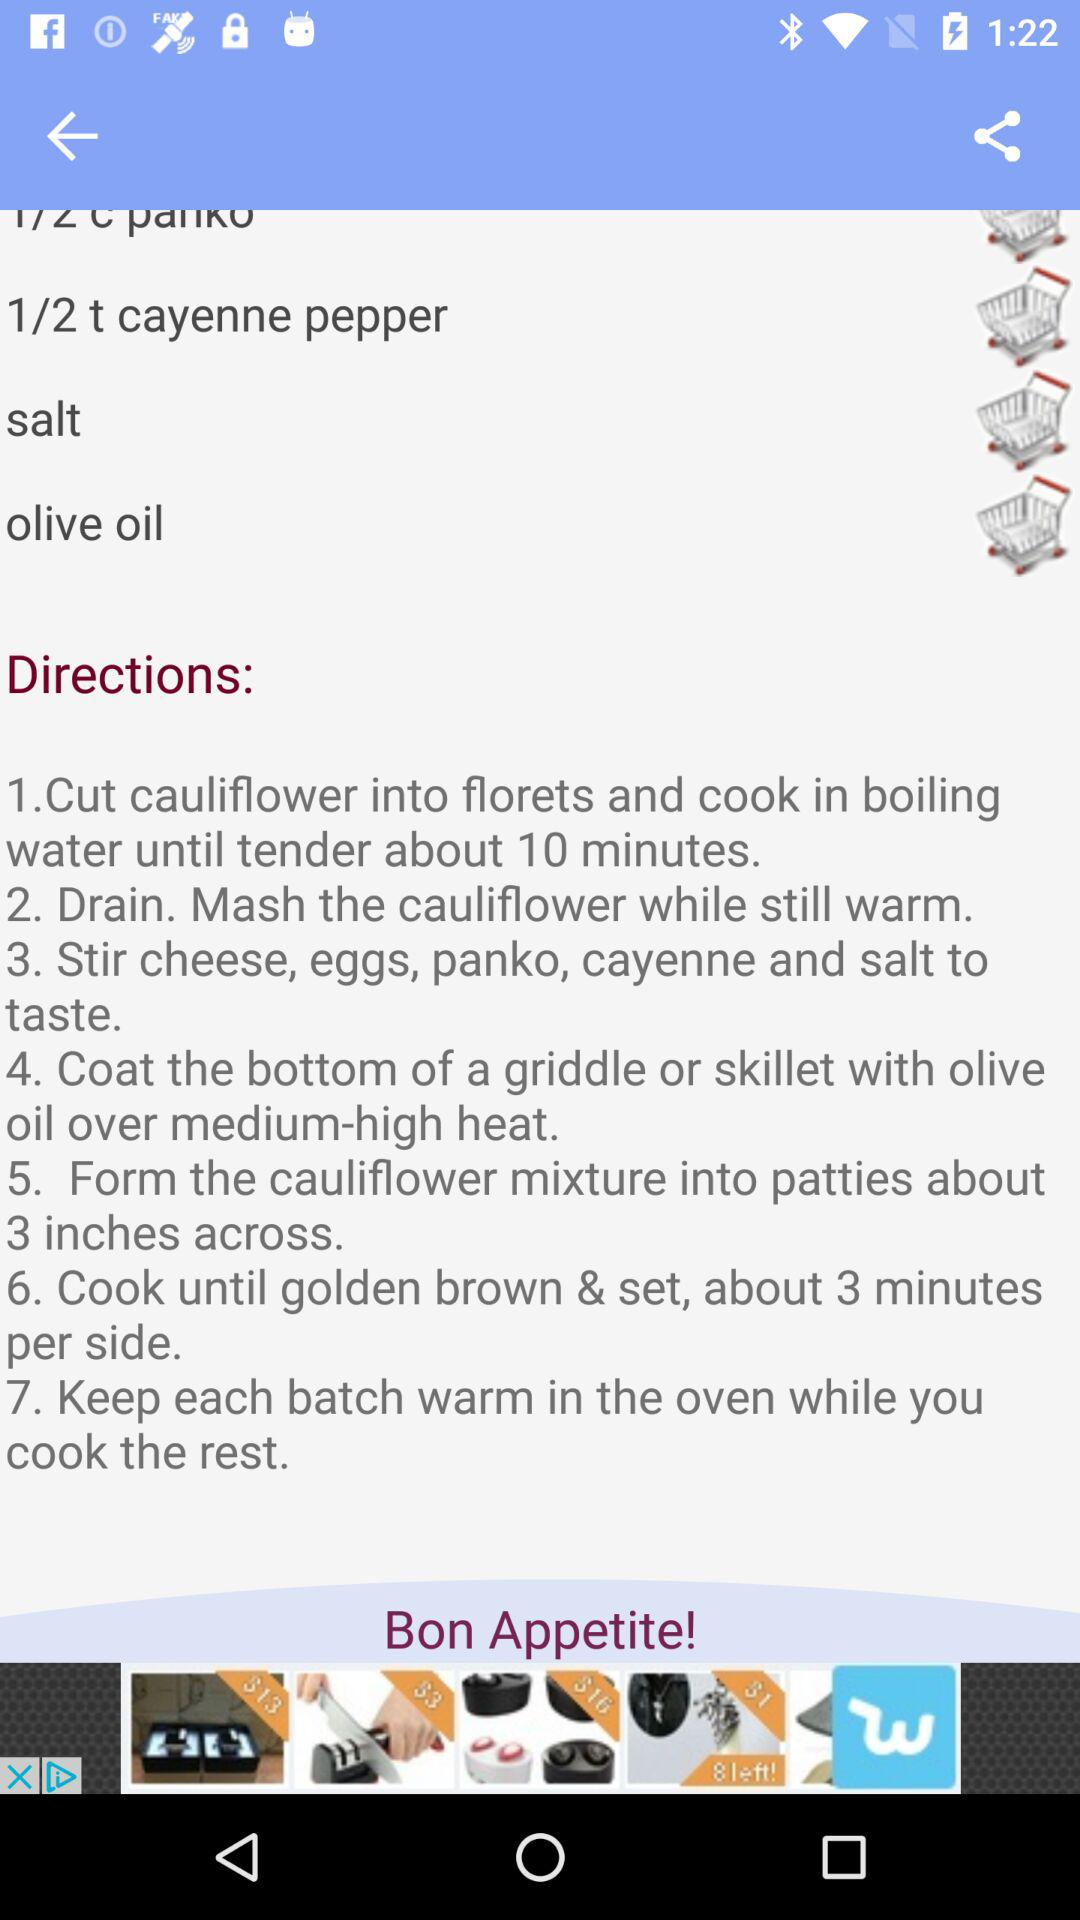How many minutes should we cook cauliflower in boiling water? You should cook the cauliflower in boiling water for about 10 minutes. 